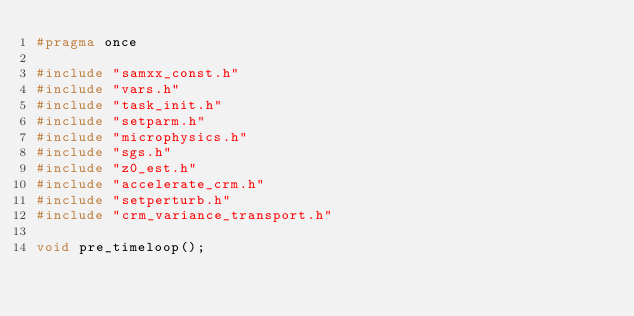<code> <loc_0><loc_0><loc_500><loc_500><_C_>#pragma once

#include "samxx_const.h"
#include "vars.h"
#include "task_init.h"
#include "setparm.h"
#include "microphysics.h"
#include "sgs.h"
#include "z0_est.h"
#include "accelerate_crm.h"
#include "setperturb.h"
#include "crm_variance_transport.h"

void pre_timeloop();

</code> 